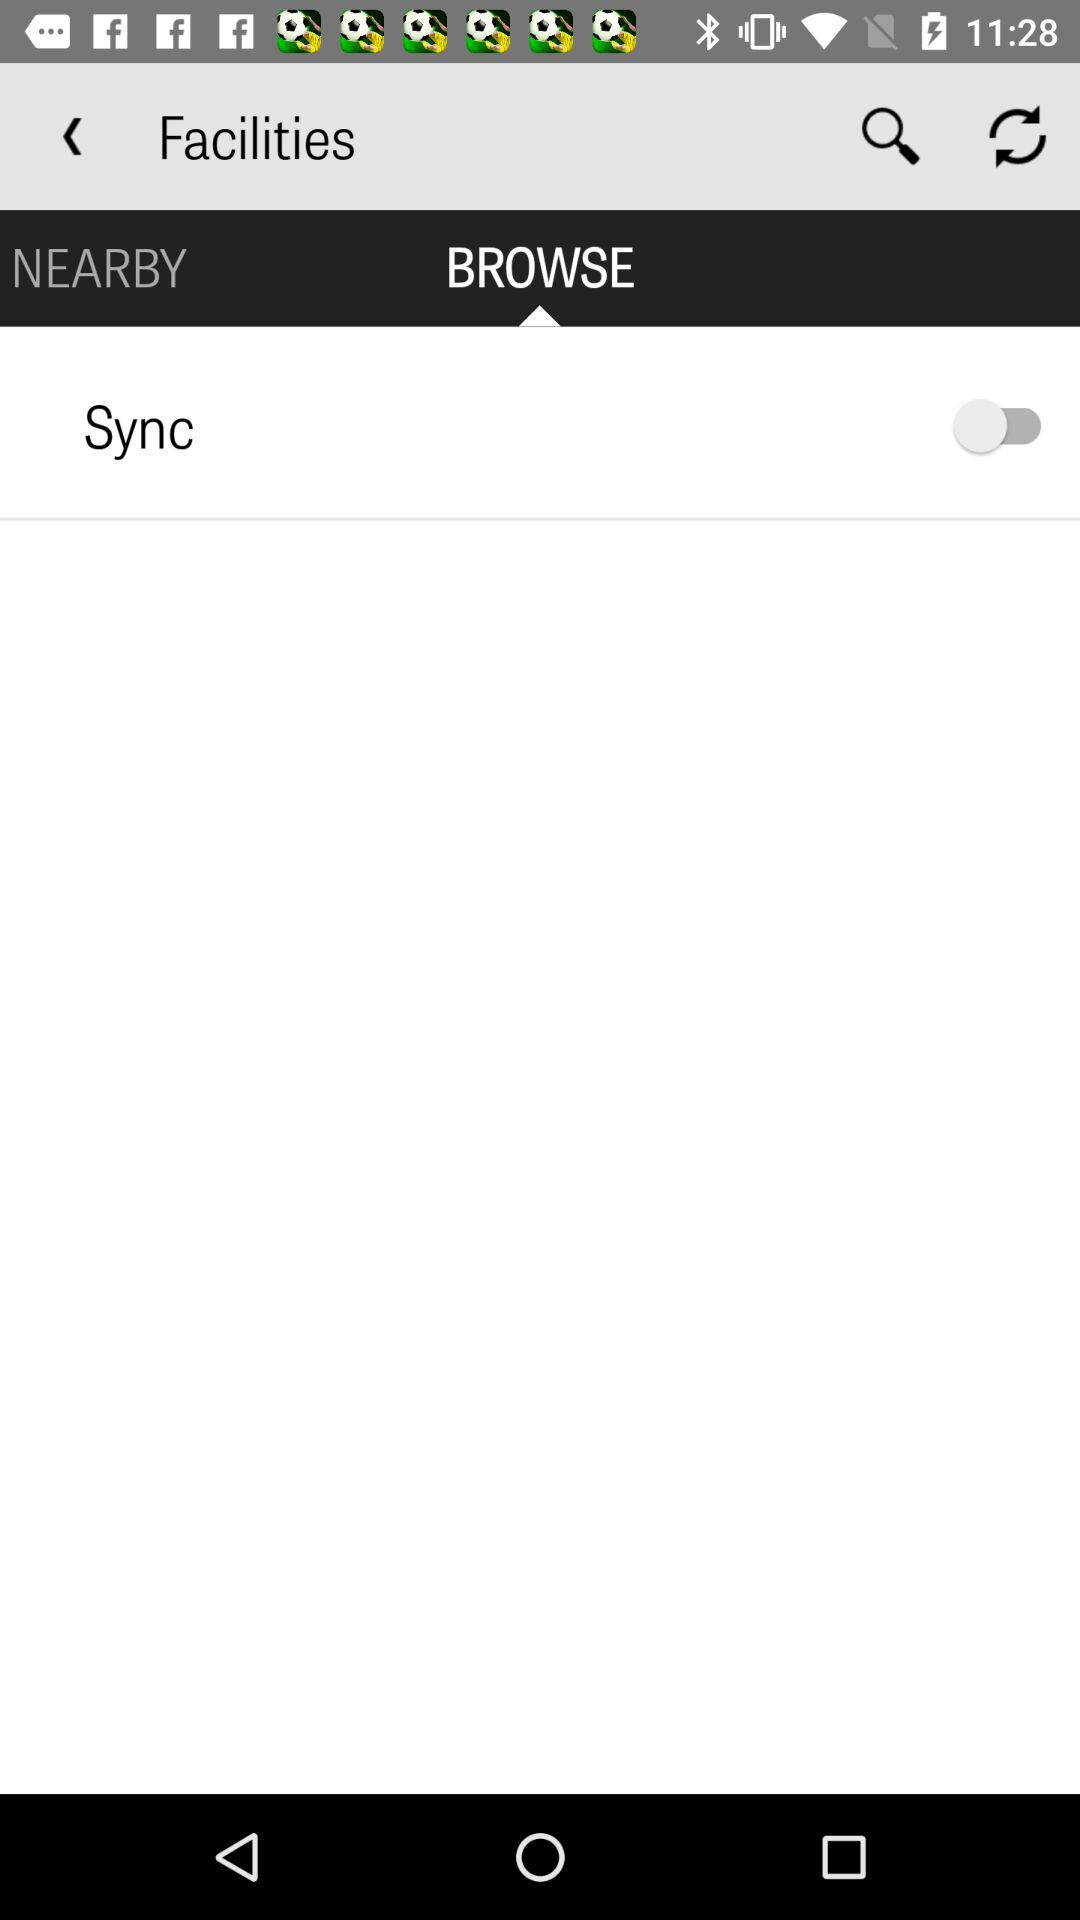How long does it take the search screen to refresh?
When the provided information is insufficient, respond with <no answer>. <no answer> 